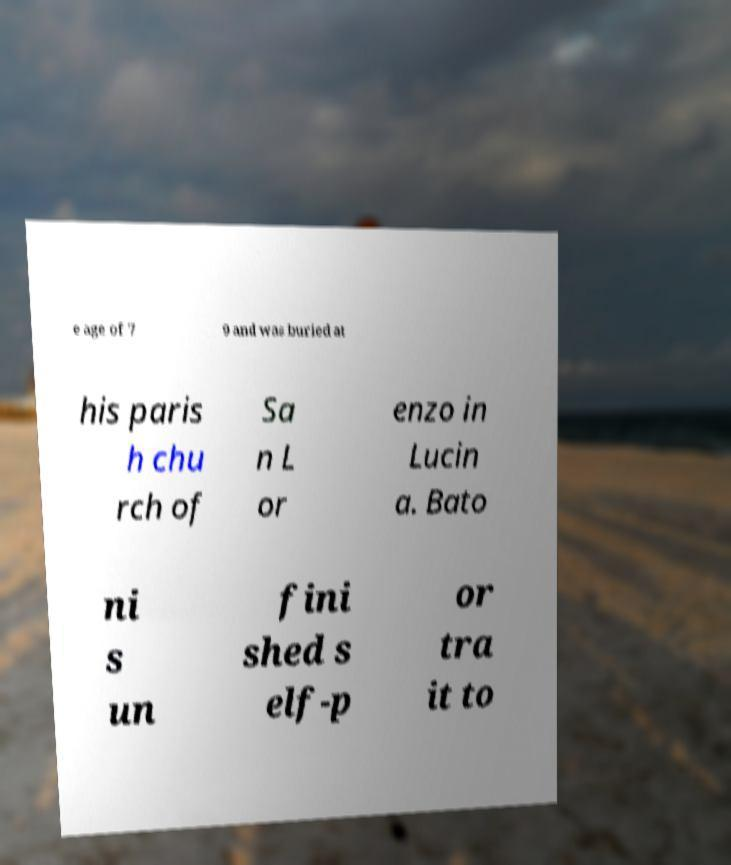What messages or text are displayed in this image? I need them in a readable, typed format. e age of 7 9 and was buried at his paris h chu rch of Sa n L or enzo in Lucin a. Bato ni s un fini shed s elf-p or tra it to 